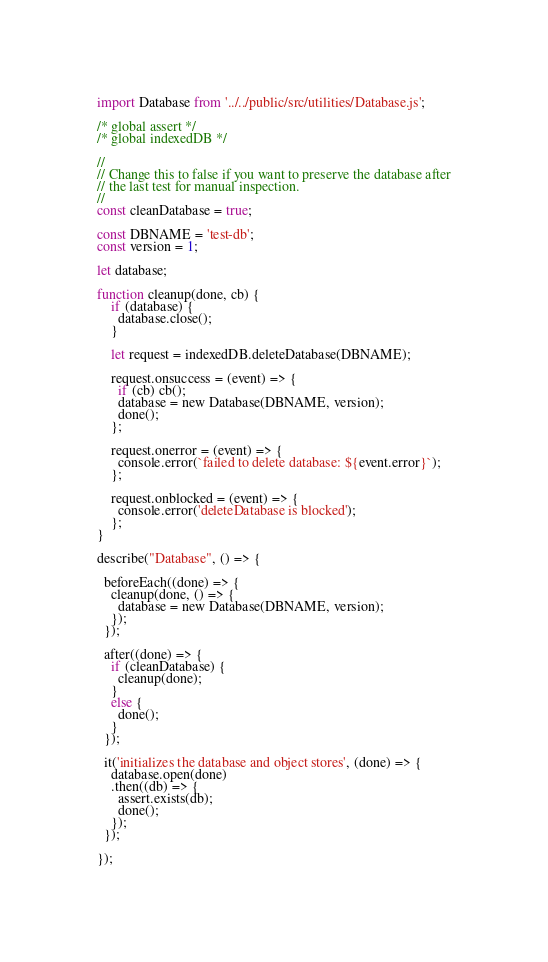Convert code to text. <code><loc_0><loc_0><loc_500><loc_500><_JavaScript_>import Database from '../../public/src/utilities/Database.js';

/* global assert */
/* global indexedDB */

//
// Change this to false if you want to preserve the database after
// the last test for manual inspection.
//
const cleanDatabase = true;

const DBNAME = 'test-db';
const version = 1;

let database;

function cleanup(done, cb) {
    if (database) {
      database.close();
    }
    
    let request = indexedDB.deleteDatabase(DBNAME);
    
    request.onsuccess = (event) => {
      if (cb) cb();
      database = new Database(DBNAME, version);
      done();
    };
    
    request.onerror = (event) => {
      console.error(`failed to delete database: ${event.error}`);
    };
    
    request.onblocked = (event) => {
      console.error('deleteDatabase is blocked');
    };
}

describe("Database", () => {
  
  beforeEach((done) => {
    cleanup(done, () => {
      database = new Database(DBNAME, version);      
    });
  });
  
  after((done) => {
    if (cleanDatabase) {
      cleanup(done);
    }
    else {
      done();
    }
  });

  it('initializes the database and object stores', (done) => {
    database.open(done)
    .then((db) => {
      assert.exists(db);
      done();
    });
  });

});</code> 